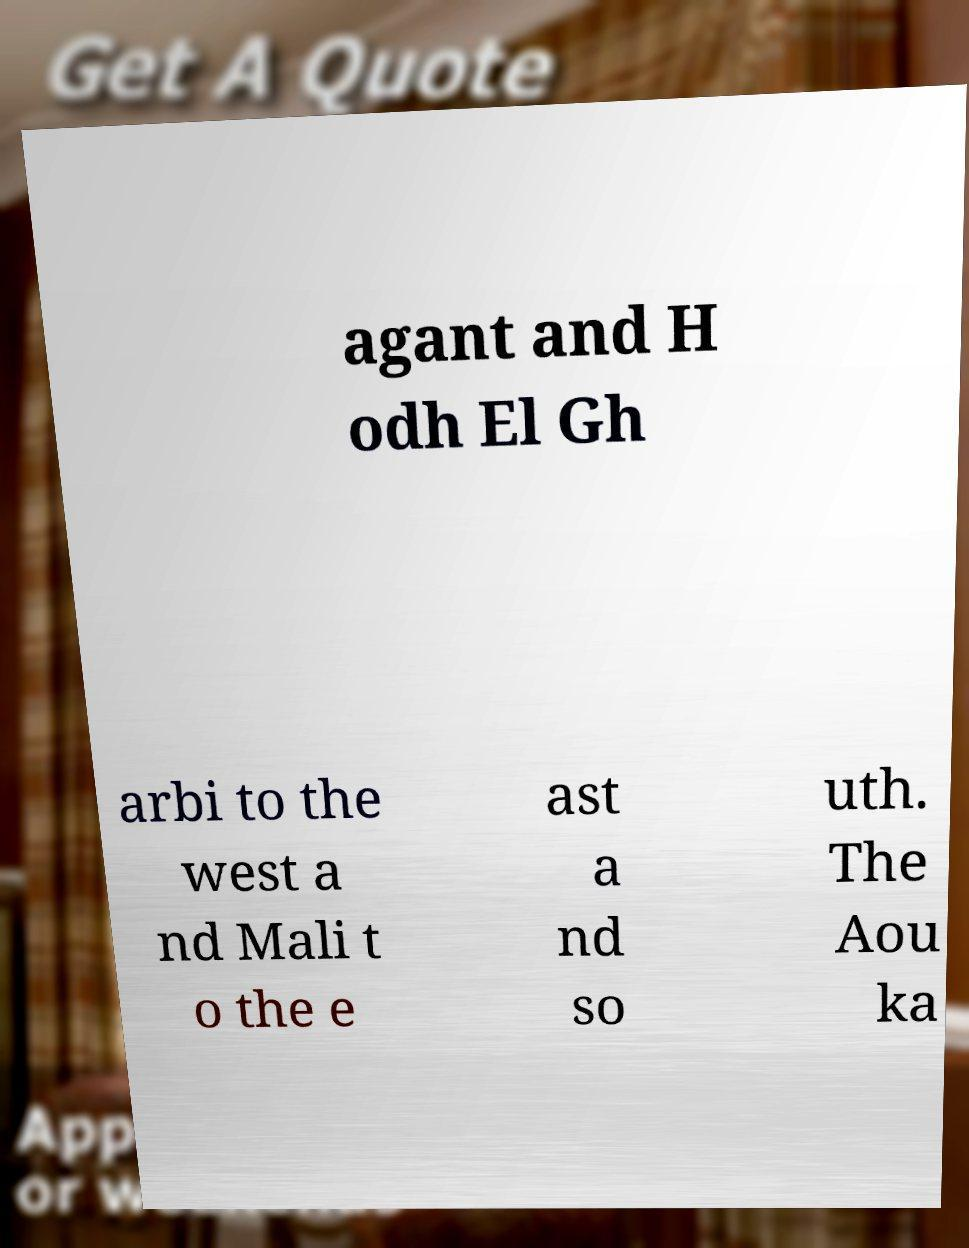I need the written content from this picture converted into text. Can you do that? agant and H odh El Gh arbi to the west a nd Mali t o the e ast a nd so uth. The Aou ka 